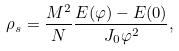Convert formula to latex. <formula><loc_0><loc_0><loc_500><loc_500>\rho _ { s } = \frac { M ^ { 2 } } { N } \frac { E ( \varphi ) - E ( 0 ) } { J _ { 0 } \varphi ^ { 2 } } ,</formula> 